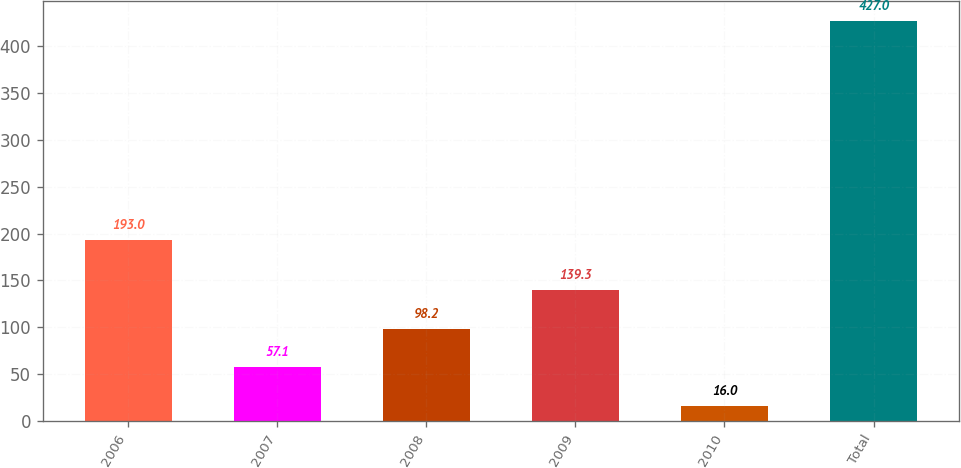<chart> <loc_0><loc_0><loc_500><loc_500><bar_chart><fcel>2006<fcel>2007<fcel>2008<fcel>2009<fcel>2010<fcel>Total<nl><fcel>193<fcel>57.1<fcel>98.2<fcel>139.3<fcel>16<fcel>427<nl></chart> 